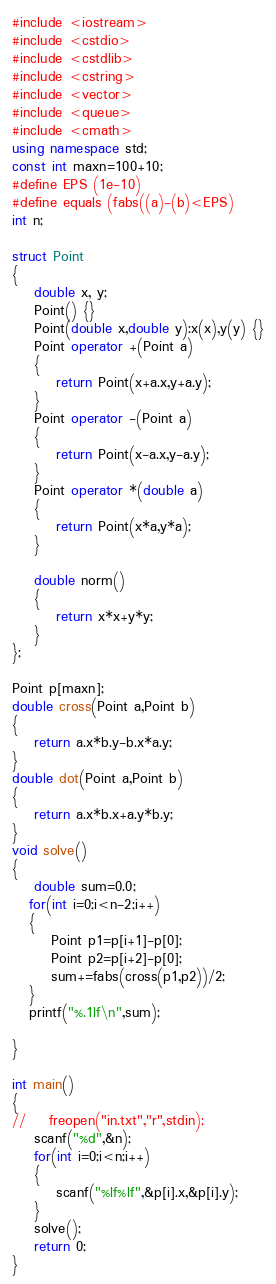<code> <loc_0><loc_0><loc_500><loc_500><_C++_>#include <iostream>
#include <cstdio>
#include <cstdlib>
#include <cstring>
#include <vector>
#include <queue>
#include <cmath>
using namespace std;
const int maxn=100+10;
#define EPS (1e-10)
#define equals (fabs((a)-(b)<EPS)
int n;

struct Point
{
    double x, y;
    Point() {}
    Point(double x,double y):x(x),y(y) {}
    Point operator +(Point a)
    {
        return Point(x+a.x,y+a.y);
    }
    Point operator -(Point a)
    {
        return Point(x-a.x,y-a.y);
    }
    Point operator *(double a)
    {
        return Point(x*a,y*a);
    }

    double norm()
    {
        return x*x+y*y;
    }
};

Point p[maxn];
double cross(Point a,Point b)
{
    return a.x*b.y-b.x*a.y;
}
double dot(Point a,Point b)
{
    return a.x*b.x+a.y*b.y;
}
void solve()
{
    double sum=0.0;
   for(int i=0;i<n-2;i++)
   {
       Point p1=p[i+1]-p[0];
       Point p2=p[i+2]-p[0];
       sum+=fabs(cross(p1,p2))/2;
   }
   printf("%.1lf\n",sum);

}

int main()
{
//    freopen("in.txt","r",stdin);
    scanf("%d",&n);
    for(int i=0;i<n;i++)
    {
        scanf("%lf%lf",&p[i].x,&p[i].y);
    }
    solve();
    return 0;
}</code> 